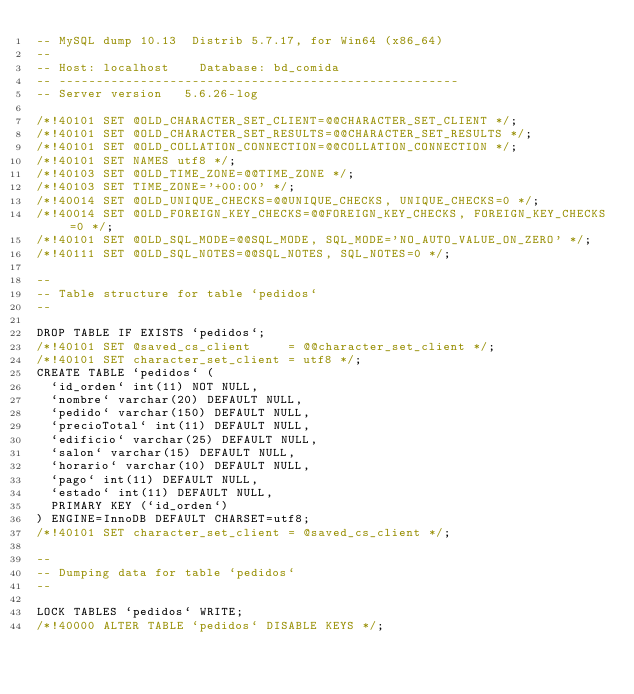<code> <loc_0><loc_0><loc_500><loc_500><_SQL_>-- MySQL dump 10.13  Distrib 5.7.17, for Win64 (x86_64)
--
-- Host: localhost    Database: bd_comida
-- ------------------------------------------------------
-- Server version	5.6.26-log

/*!40101 SET @OLD_CHARACTER_SET_CLIENT=@@CHARACTER_SET_CLIENT */;
/*!40101 SET @OLD_CHARACTER_SET_RESULTS=@@CHARACTER_SET_RESULTS */;
/*!40101 SET @OLD_COLLATION_CONNECTION=@@COLLATION_CONNECTION */;
/*!40101 SET NAMES utf8 */;
/*!40103 SET @OLD_TIME_ZONE=@@TIME_ZONE */;
/*!40103 SET TIME_ZONE='+00:00' */;
/*!40014 SET @OLD_UNIQUE_CHECKS=@@UNIQUE_CHECKS, UNIQUE_CHECKS=0 */;
/*!40014 SET @OLD_FOREIGN_KEY_CHECKS=@@FOREIGN_KEY_CHECKS, FOREIGN_KEY_CHECKS=0 */;
/*!40101 SET @OLD_SQL_MODE=@@SQL_MODE, SQL_MODE='NO_AUTO_VALUE_ON_ZERO' */;
/*!40111 SET @OLD_SQL_NOTES=@@SQL_NOTES, SQL_NOTES=0 */;

--
-- Table structure for table `pedidos`
--

DROP TABLE IF EXISTS `pedidos`;
/*!40101 SET @saved_cs_client     = @@character_set_client */;
/*!40101 SET character_set_client = utf8 */;
CREATE TABLE `pedidos` (
  `id_orden` int(11) NOT NULL,
  `nombre` varchar(20) DEFAULT NULL,
  `pedido` varchar(150) DEFAULT NULL,
  `precioTotal` int(11) DEFAULT NULL,
  `edificio` varchar(25) DEFAULT NULL,
  `salon` varchar(15) DEFAULT NULL,
  `horario` varchar(10) DEFAULT NULL,
  `pago` int(11) DEFAULT NULL,
  `estado` int(11) DEFAULT NULL,
  PRIMARY KEY (`id_orden`)
) ENGINE=InnoDB DEFAULT CHARSET=utf8;
/*!40101 SET character_set_client = @saved_cs_client */;

--
-- Dumping data for table `pedidos`
--

LOCK TABLES `pedidos` WRITE;
/*!40000 ALTER TABLE `pedidos` DISABLE KEYS */;</code> 